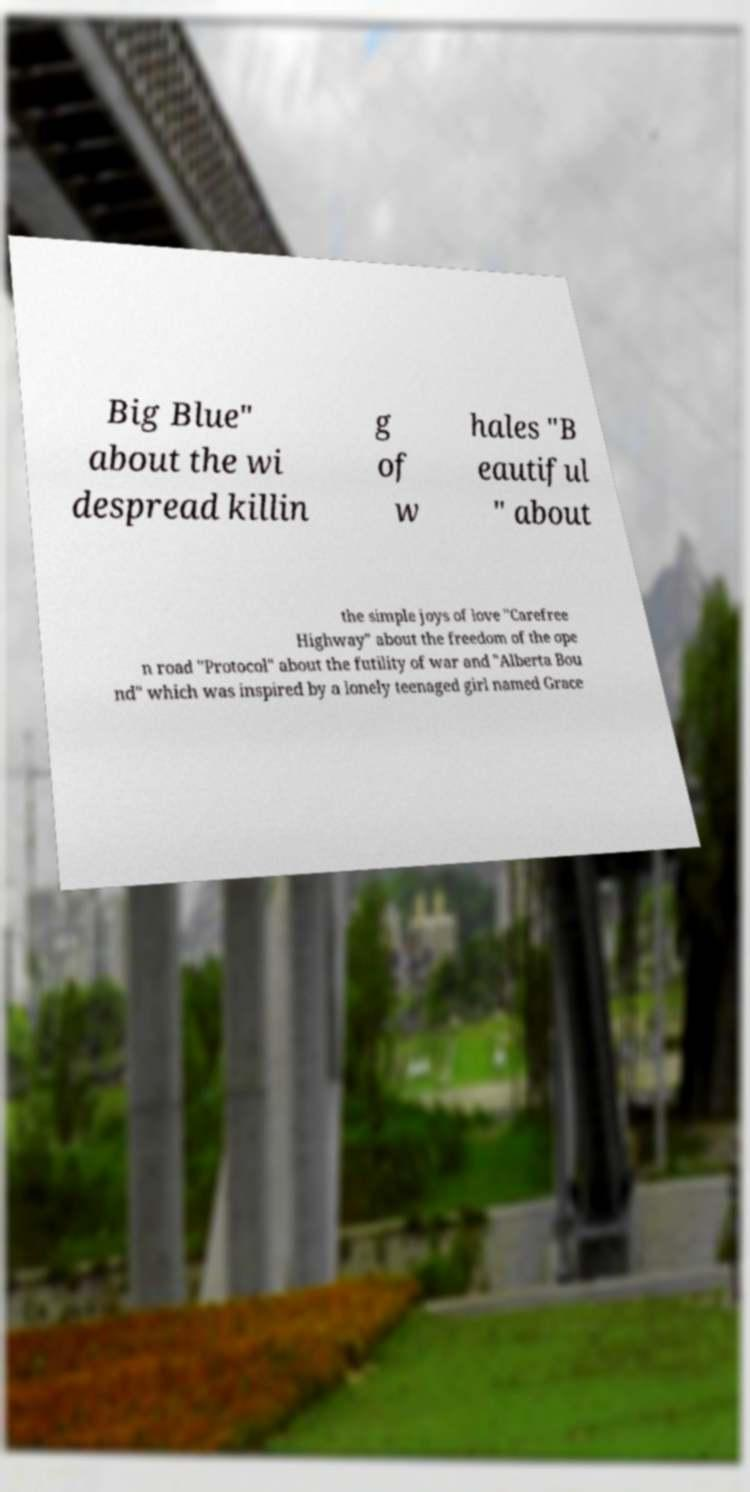Could you assist in decoding the text presented in this image and type it out clearly? Big Blue" about the wi despread killin g of w hales "B eautiful " about the simple joys of love "Carefree Highway" about the freedom of the ope n road "Protocol" about the futility of war and "Alberta Bou nd" which was inspired by a lonely teenaged girl named Grace 